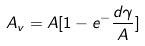Convert formula to latex. <formula><loc_0><loc_0><loc_500><loc_500>A _ { v } = A [ 1 - e ^ { - } \frac { d \gamma } { A } ]</formula> 